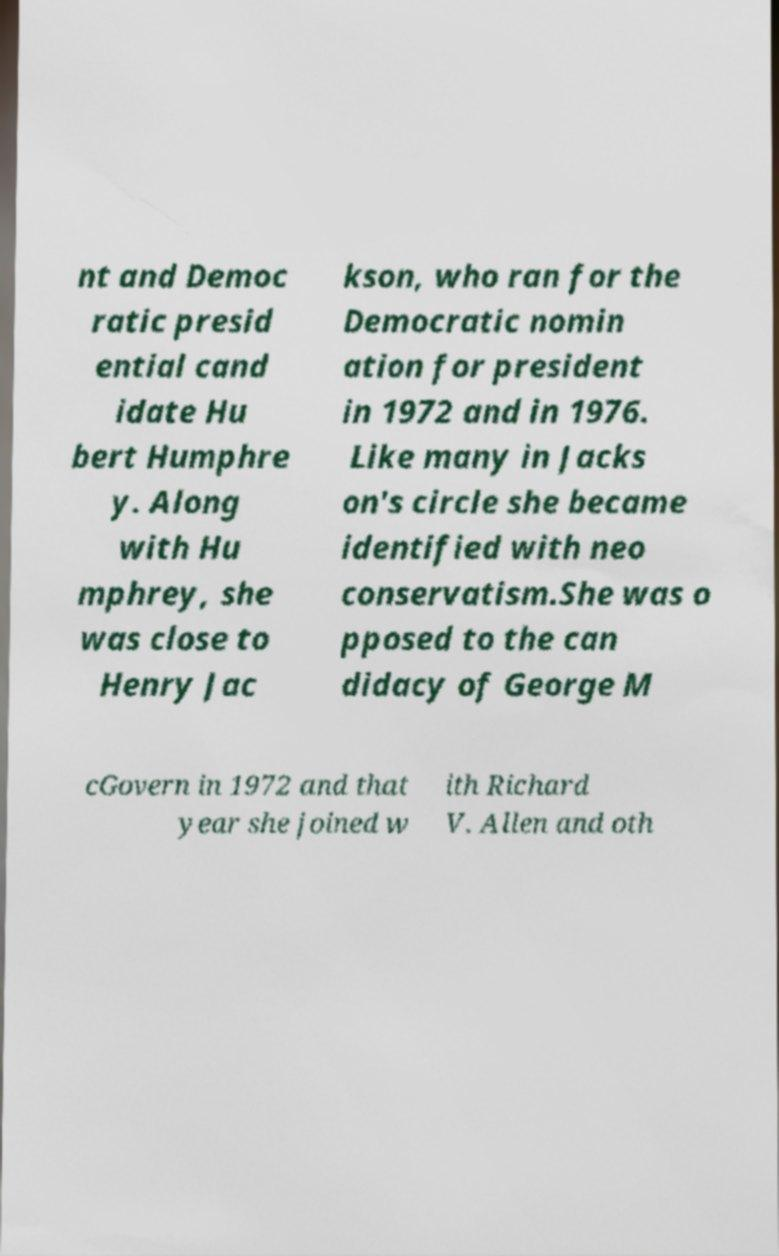For documentation purposes, I need the text within this image transcribed. Could you provide that? nt and Democ ratic presid ential cand idate Hu bert Humphre y. Along with Hu mphrey, she was close to Henry Jac kson, who ran for the Democratic nomin ation for president in 1972 and in 1976. Like many in Jacks on's circle she became identified with neo conservatism.She was o pposed to the can didacy of George M cGovern in 1972 and that year she joined w ith Richard V. Allen and oth 